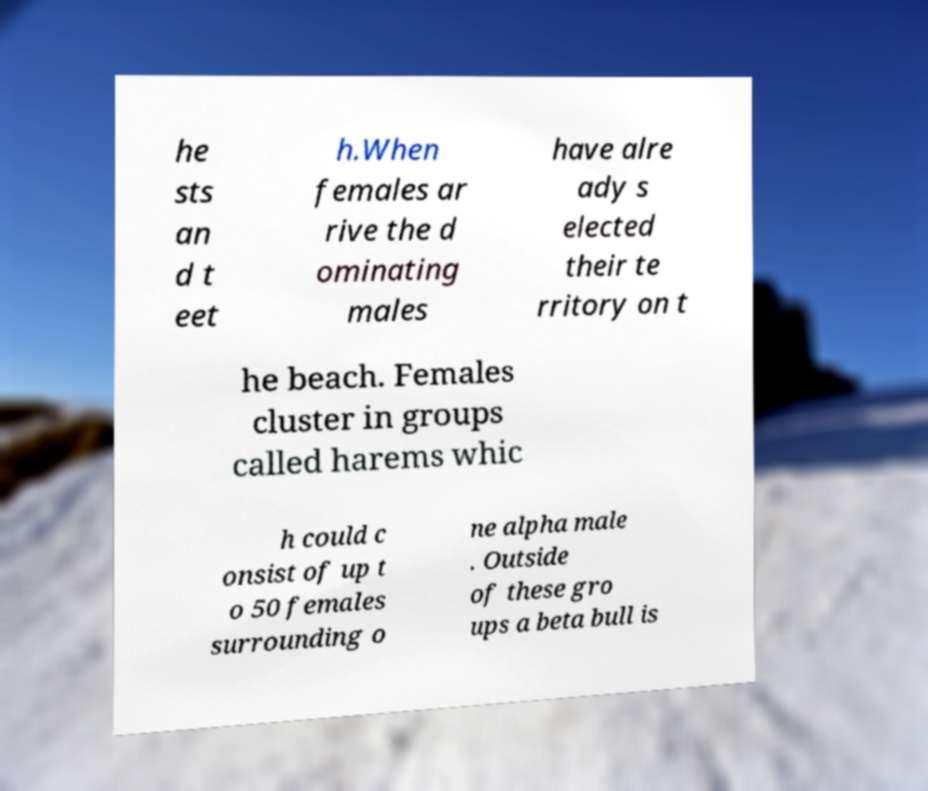For documentation purposes, I need the text within this image transcribed. Could you provide that? he sts an d t eet h.When females ar rive the d ominating males have alre ady s elected their te rritory on t he beach. Females cluster in groups called harems whic h could c onsist of up t o 50 females surrounding o ne alpha male . Outside of these gro ups a beta bull is 